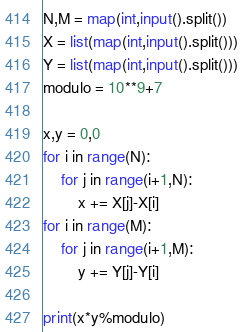<code> <loc_0><loc_0><loc_500><loc_500><_Python_>N,M = map(int,input().split())
X = list(map(int,input().split()))
Y = list(map(int,input().split()))
modulo = 10**9+7

x,y = 0,0
for i in range(N):
    for j in range(i+1,N):
        x += X[j]-X[i]
for i in range(M):
    for j in range(i+1,M):
        y += Y[j]-Y[i]

print(x*y%modulo)</code> 